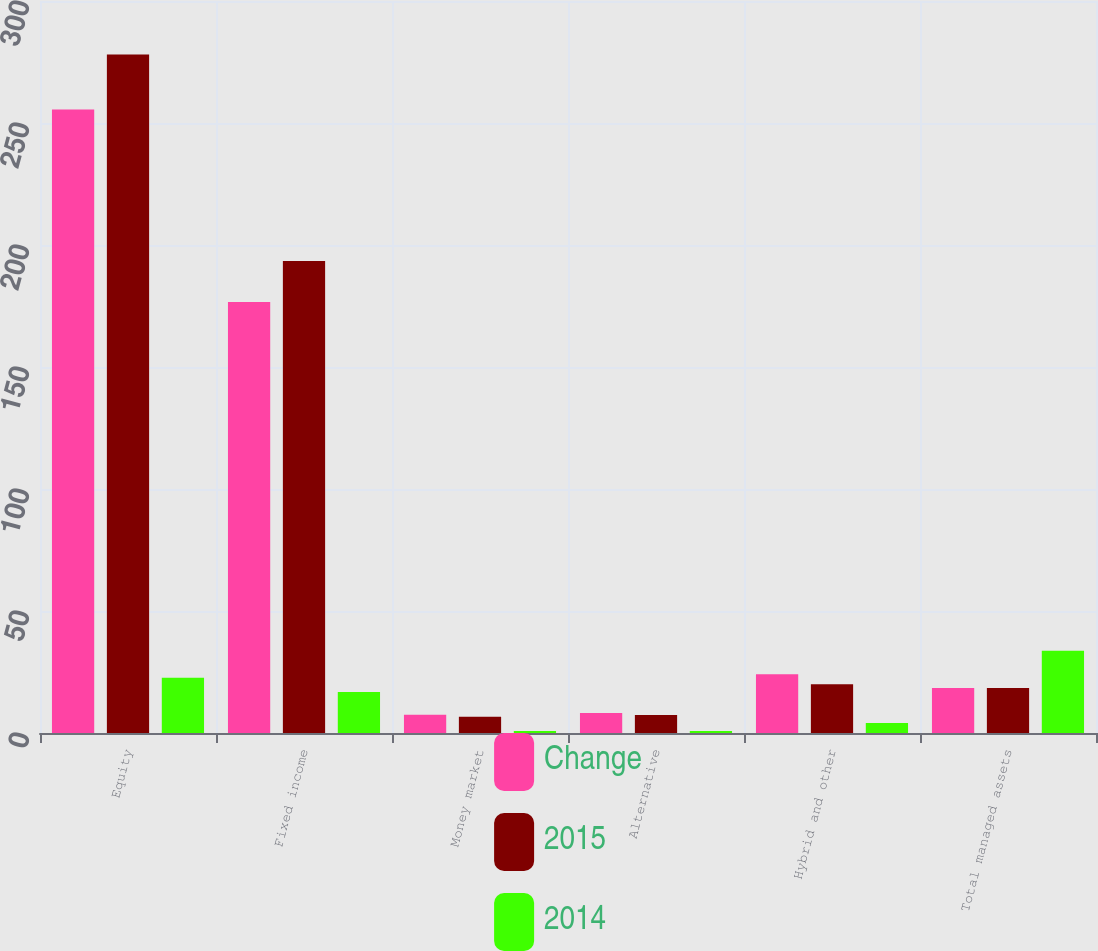Convert chart. <chart><loc_0><loc_0><loc_500><loc_500><stacked_bar_chart><ecel><fcel>Equity<fcel>Fixed income<fcel>Money market<fcel>Alternative<fcel>Hybrid and other<fcel>Total managed assets<nl><fcel>Change<fcel>255.5<fcel>176.6<fcel>7.5<fcel>8.2<fcel>24.1<fcel>18.4<nl><fcel>2015<fcel>278.1<fcel>193.4<fcel>6.7<fcel>7.4<fcel>20<fcel>18.4<nl><fcel>2014<fcel>22.6<fcel>16.8<fcel>0.8<fcel>0.8<fcel>4.1<fcel>33.7<nl></chart> 